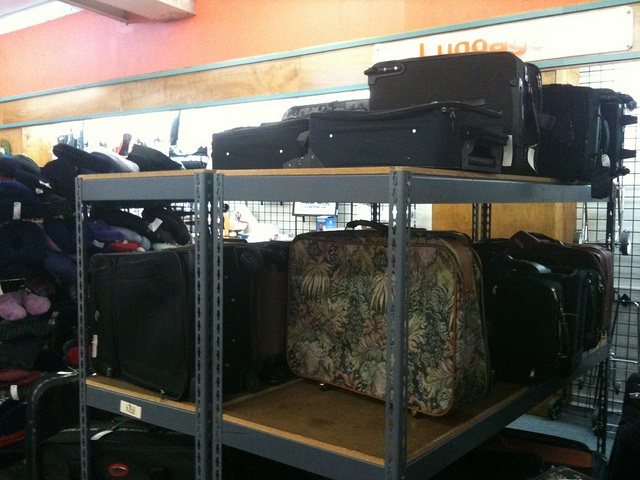Describe the objects in this image and their specific colors. I can see suitcase in pink, black, and gray tones, suitcase in pink, black, gray, purple, and darkgray tones, suitcase in pink, black, and gray tones, suitcase in pink, black, gray, darkgray, and purple tones, and suitcase in pink, black, gray, and blue tones in this image. 